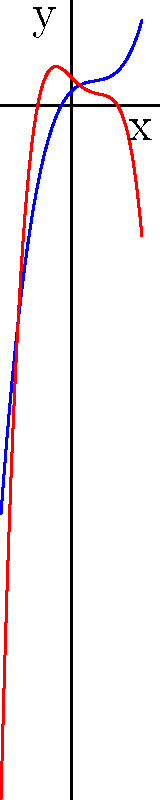As a copyright infringement protection expert, you're analyzing the behavior of two functions that represent the growth of original content (blue) versus plagiarized content (red) over time. Based on the end behavior of these polynomial functions, which one will ultimately dominate in the long run, and how might this impact your strategy for protecting content creators? To determine which function will dominate in the long run, we need to analyze their end behavior:

1. Identify the degree and leading coefficient of each function:
   - Blue function (f(x)): Cubic (degree 3), positive leading coefficient
   - Red function (g(x)): Quartic (degree 4), negative leading coefficient

2. Analyze end behavior:
   - f(x): As a cubic function with a positive leading coefficient, it will approach positive infinity as x approaches positive infinity, and negative infinity as x approaches negative infinity.
   - g(x): As a quartic function with a negative leading coefficient, it will approach negative infinity as x approaches both positive and negative infinity.

3. Compare end behaviors:
   - As x approaches positive infinity: g(x) will decrease faster than f(x) increases.
   - As x approaches negative infinity: g(x) will decrease faster than f(x) decreases.

4. Conclusion:
   The red function (g(x)) will dominate in the long run, as it has a higher degree and will grow more quickly in absolute value than the blue function (f(x)).

5. Impact on strategy:
   This suggests that plagiarized content may outpace original content growth in the long term. As a copyright protection expert, you should focus on developing more aggressive and proactive strategies to combat the rapid spread of plagiarized content, such as implementing advanced detection algorithms and advocating for stricter penalties for infringement.
Answer: The red function (g(x)) will dominate, necessitating more aggressive copyright protection strategies. 